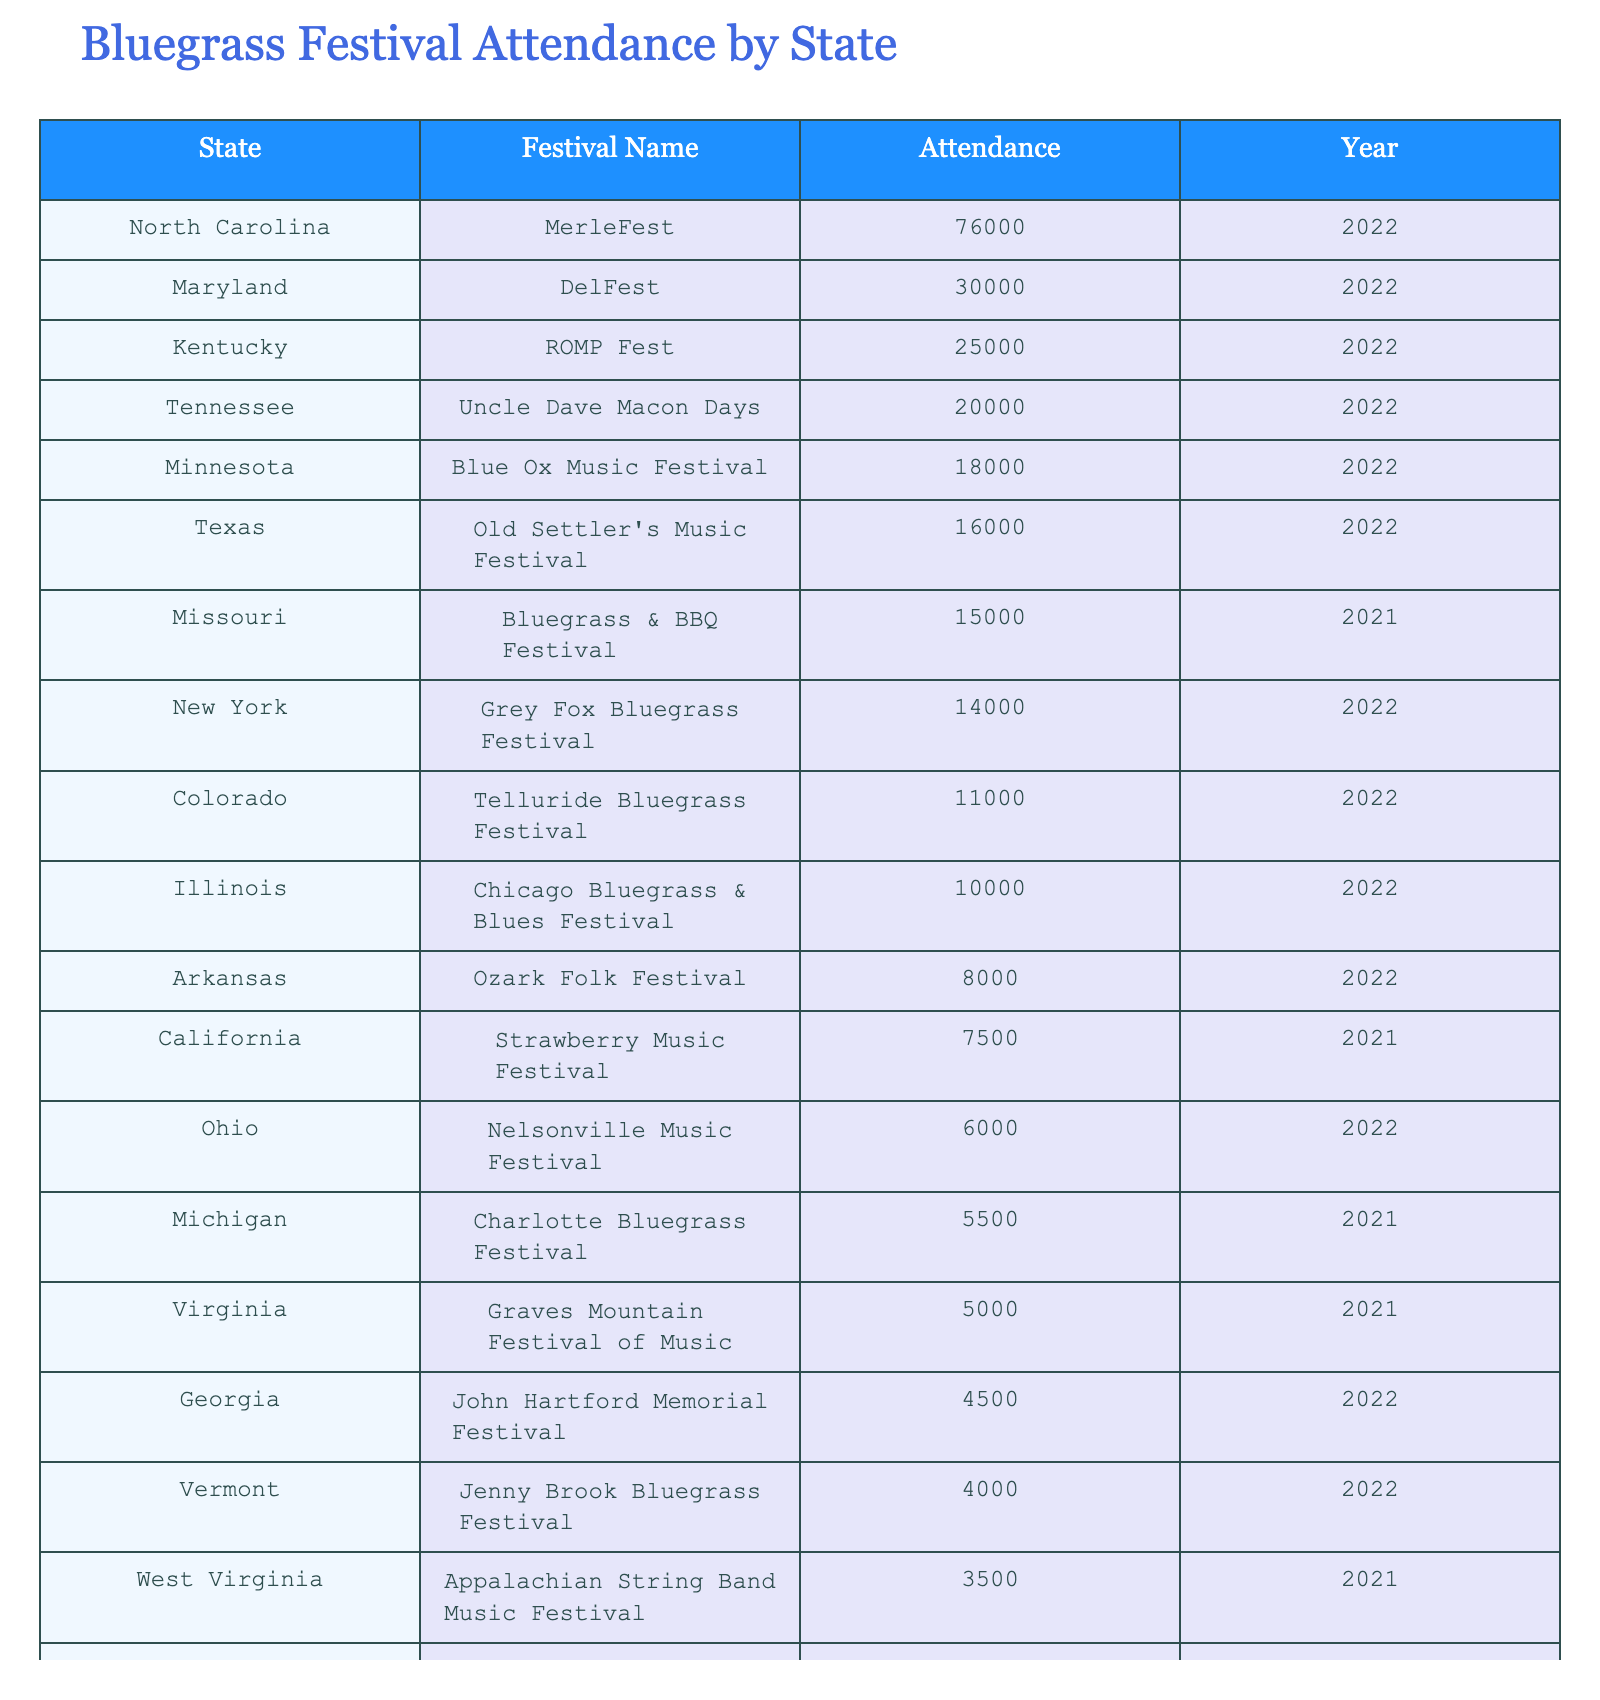What's the largest attendance recorded in the table? Looking through the attendance numbers, North Carolina's MerleFest in 2022 has the highest attendance with 76,000 people.
Answer: 76,000 Which festival in Tennessee had an attendance of 20,000? The Uncle Dave Macon Days festival in Tennessee held in 2022 recorded an attendance of 20,000.
Answer: Uncle Dave Macon Days How many festivals had an attendance of over 20,000? There are two festivals that had attendance numbers exceeding 20,000: North Carolina's MerleFest with 76,000 and Maryland's DelFest with 30,000.
Answer: 2 What is the average attendance for festivals held in 2022? The festivals held in 2022 had the following attendance: 25,000 (Kentucky) + 76,000 (North Carolina) + 20,000 (Tennessee) + 30,000 (Maryland) + 14,000 (New York) + 4,000 (Vermont) + 16,000 (Texas) + 18,000 (Minnesota) + 10,000 (Illinois) + 4,500 (Georgia) + 11,000 (Colorado) + 3,000 (Washington) =  174,500. There were 12 festivals held in 2022, so the average attendance is 174,500 / 12 ≈ 14,583.33.
Answer: 14,583 Which state had the least attendance and what was the number? Virginia had the least attendance with only 5,000 people at the Graves Mountain Festival of Music in 2021.
Answer: 5,000 Does Georgia have any festival listed in 2021? No, Georgia does not have any festival listed for the year 2021; the only record for Georgia in the table is for the year 2022.
Answer: No What is the difference in attendance between the largest and smallest festival? The largest festival is North Carolina's MerleFest with 76,000 attendees, while the smallest is Pennsylvania's Smoked Country Jam with 2,500 attendees. The difference in attendance is 76,000 - 2,500 = 73,500.
Answer: 73,500 Which festival had the highest attendance in 2021? In 2021, the festival with the highest attendance is the Missouri Bluegrass & BBQ Festival with 15,000 attendees.
Answer: 15,000 Are there more festivals with attendance over 10,000 or under 10,000? Analyzing the table, five festivals had attendance over 10,000 (North Carolina, Maryland, Kentucky, Tennessee, New York) while six had attendance under 10,000 (California, Virginia, Georgia, Ohio, West Virginia, Arkansas, Illinois, Minnesota, Washington, and Michigan). Thus, there are more festivals under 10,000.
Answer: Under 10,000 What percentage of attendees came from festivals held in North Carolina? The total attendance recorded across all festivals is 367,500. North Carolina's MerleFest had 76,000 attendees. The percentage is (76,000 / 367,500) * 100 ≈ 20.67%.
Answer: 20.67% Which two states had festivals listed in the year 2021 and what were their attendances? The states with festivals in 2021 are California with 7,500 attendees and Virginia with 5,000 attendees.
Answer: California and Virginia, 7,500 and 5,000 respectively 